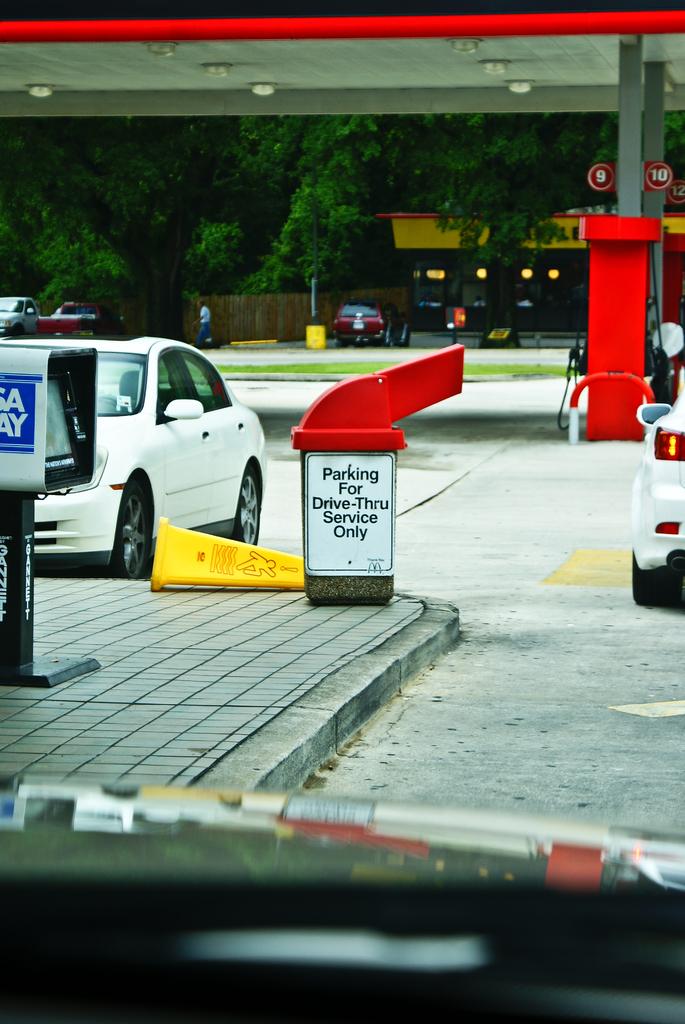Who does the sign say the parking is for?
Offer a terse response. Drive thru service only. What kind of newspaper is in the box?
Your answer should be compact. Usa today. 